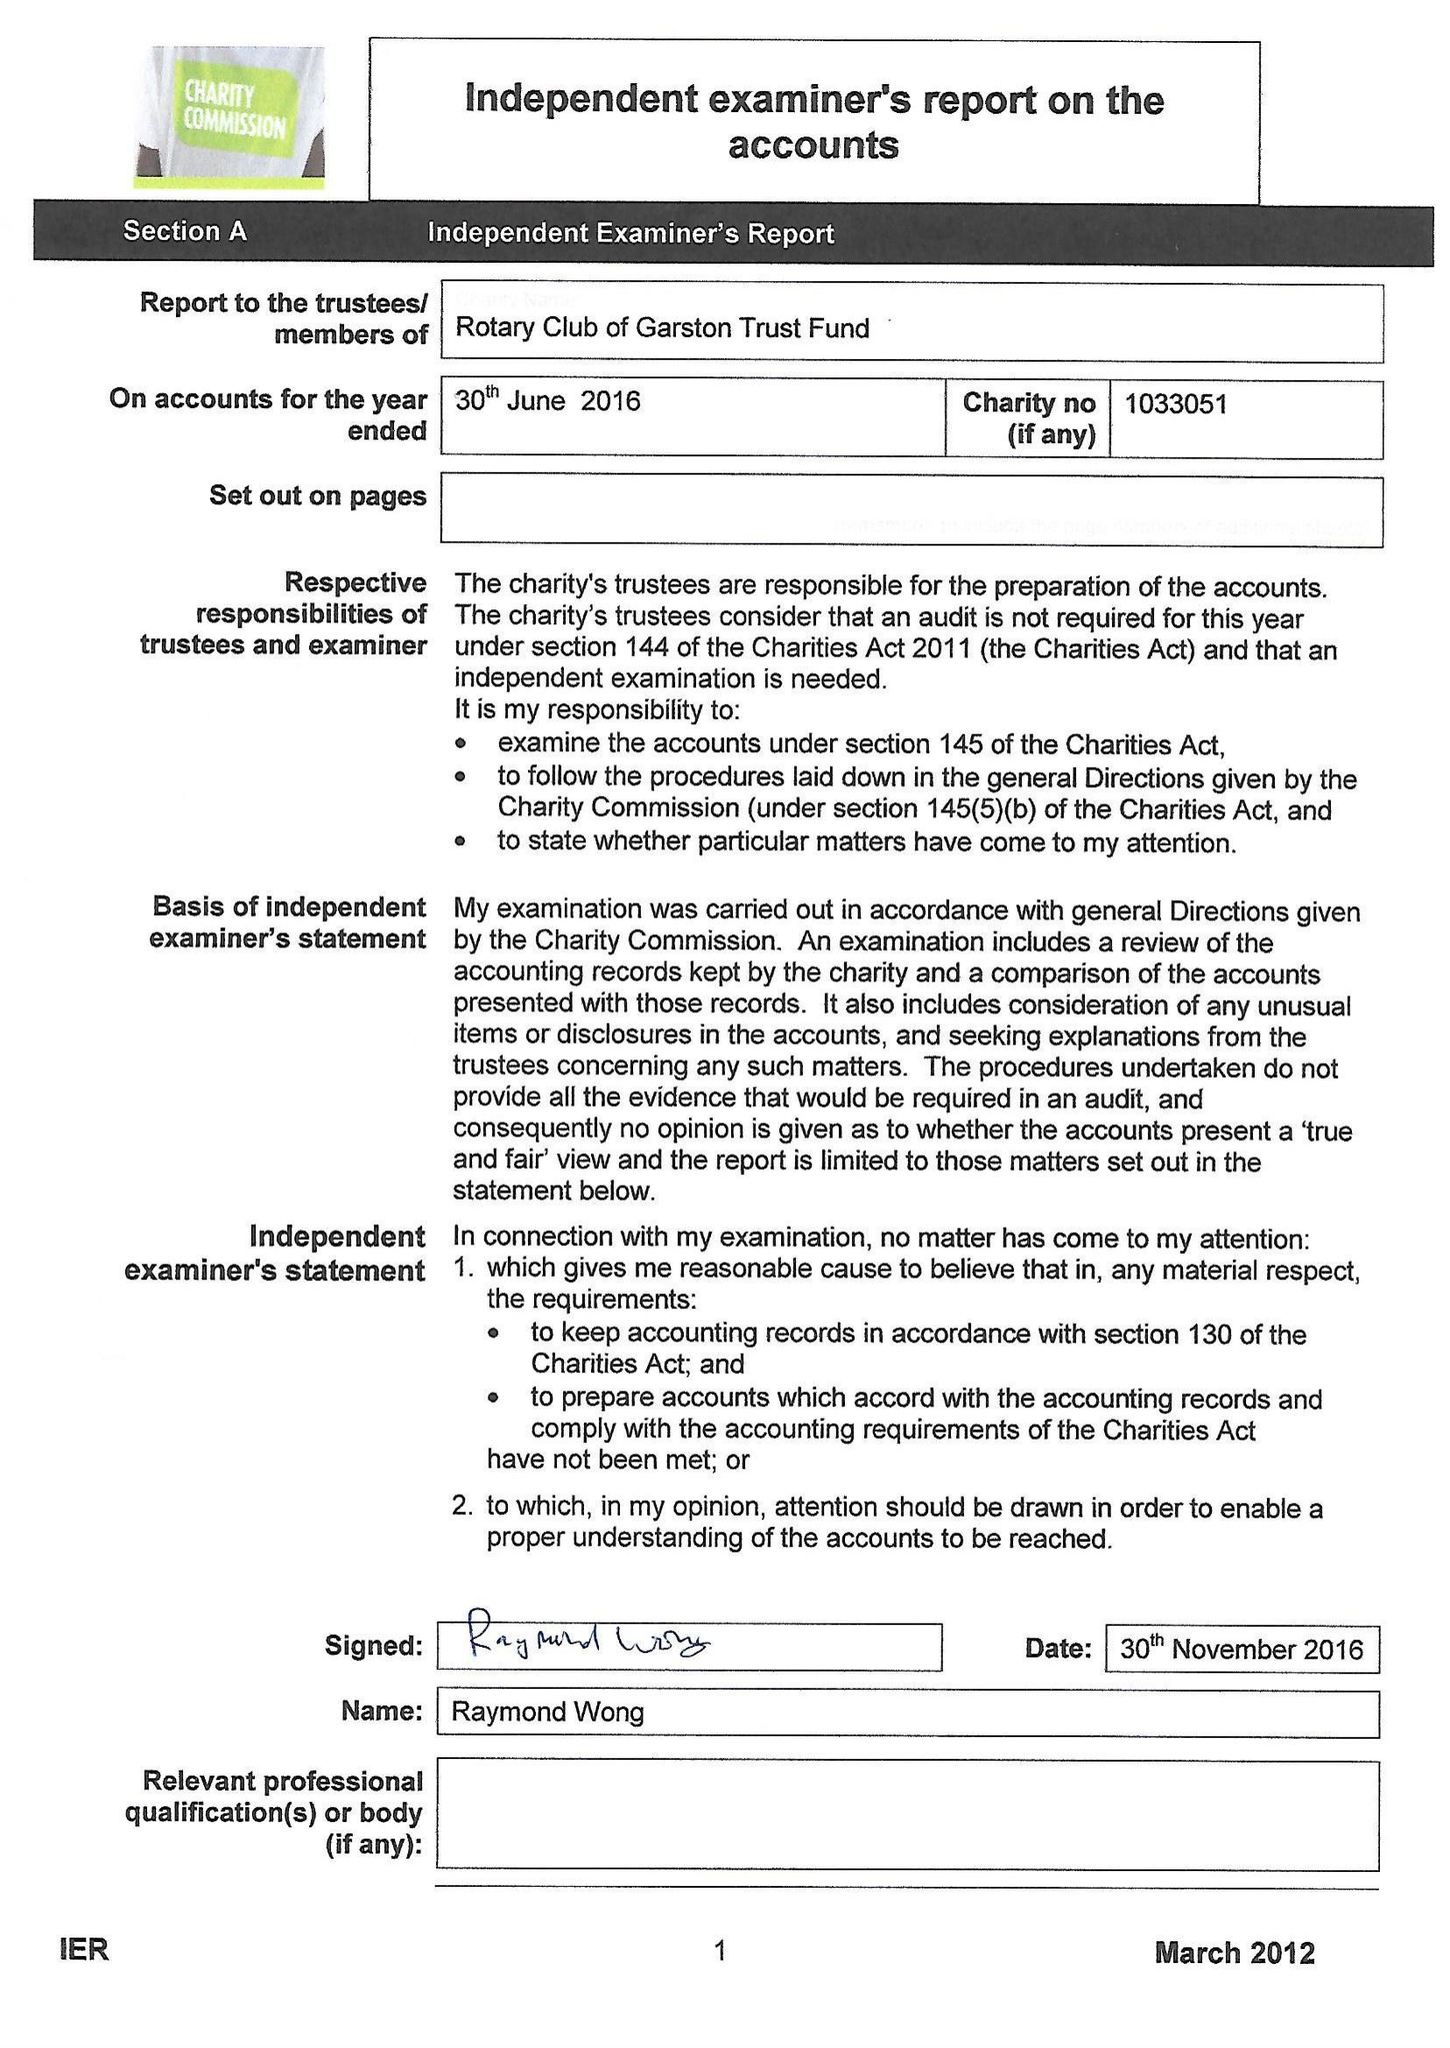What is the value for the spending_annually_in_british_pounds?
Answer the question using a single word or phrase. 40714.00 